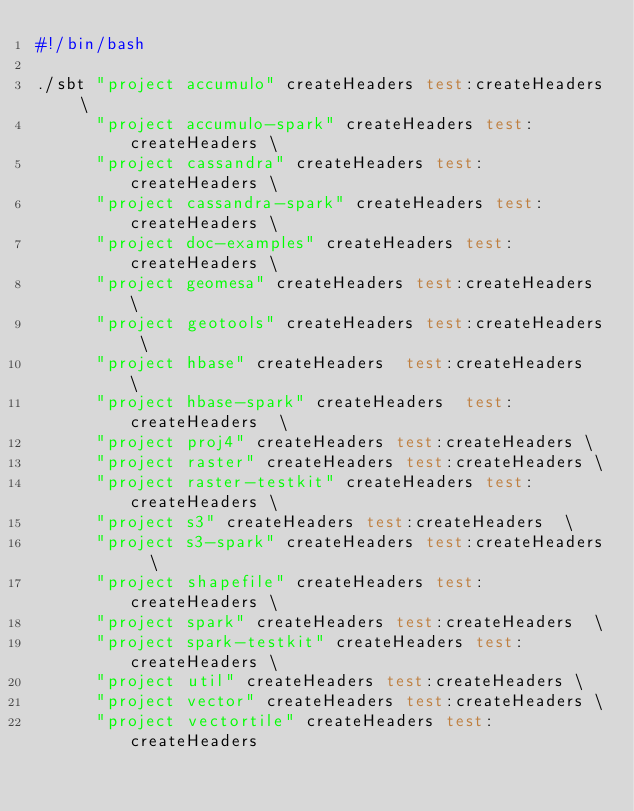<code> <loc_0><loc_0><loc_500><loc_500><_Bash_>#!/bin/bash

./sbt "project accumulo" createHeaders test:createHeaders \
      "project accumulo-spark" createHeaders test:createHeaders \
      "project cassandra" createHeaders test:createHeaders \
      "project cassandra-spark" createHeaders test:createHeaders \
      "project doc-examples" createHeaders test:createHeaders \
      "project geomesa" createHeaders test:createHeaders \
      "project geotools" createHeaders test:createHeaders \
      "project hbase" createHeaders  test:createHeaders  \
      "project hbase-spark" createHeaders  test:createHeaders  \
      "project proj4" createHeaders test:createHeaders \
      "project raster" createHeaders test:createHeaders \
      "project raster-testkit" createHeaders test:createHeaders \
      "project s3" createHeaders test:createHeaders  \
      "project s3-spark" createHeaders test:createHeaders  \
      "project shapefile" createHeaders test:createHeaders \
      "project spark" createHeaders test:createHeaders  \
      "project spark-testkit" createHeaders test:createHeaders \
      "project util" createHeaders test:createHeaders \
      "project vector" createHeaders test:createHeaders \
      "project vectortile" createHeaders test:createHeaders
</code> 